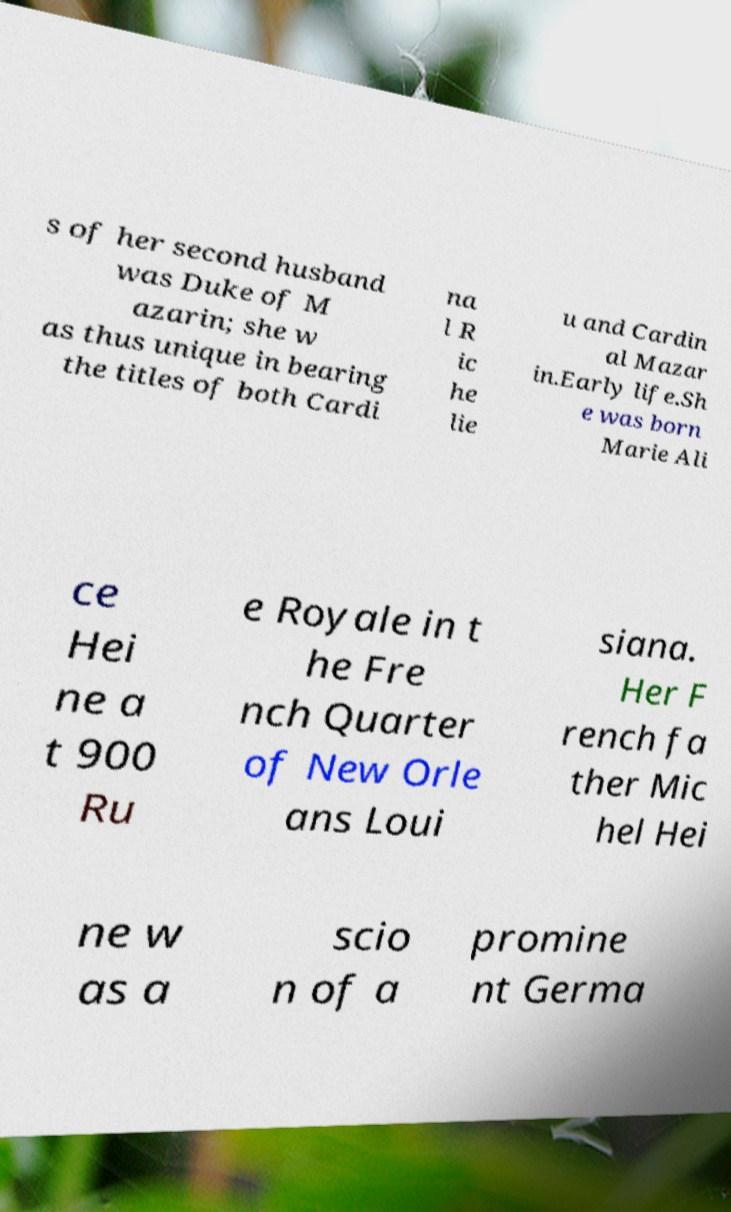Please identify and transcribe the text found in this image. s of her second husband was Duke of M azarin; she w as thus unique in bearing the titles of both Cardi na l R ic he lie u and Cardin al Mazar in.Early life.Sh e was born Marie Ali ce Hei ne a t 900 Ru e Royale in t he Fre nch Quarter of New Orle ans Loui siana. Her F rench fa ther Mic hel Hei ne w as a scio n of a promine nt Germa 